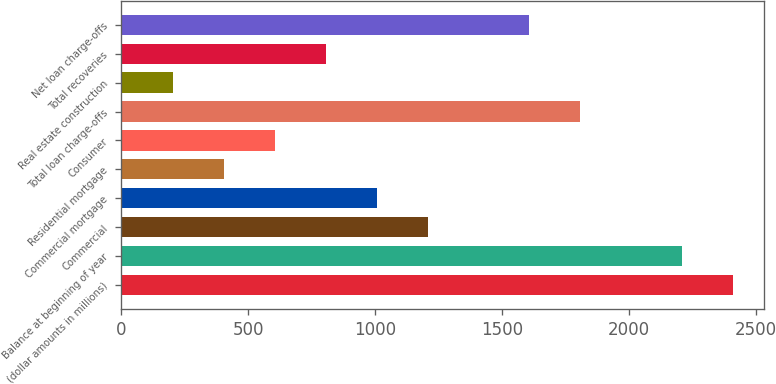Convert chart to OTSL. <chart><loc_0><loc_0><loc_500><loc_500><bar_chart><fcel>(dollar amounts in millions)<fcel>Balance at beginning of year<fcel>Commercial<fcel>Commercial mortgage<fcel>Residential mortgage<fcel>Consumer<fcel>Total loan charge-offs<fcel>Real estate construction<fcel>Total recoveries<fcel>Net loan charge-offs<nl><fcel>2411.71<fcel>2210.85<fcel>1206.55<fcel>1005.69<fcel>403.11<fcel>603.97<fcel>1809.13<fcel>202.25<fcel>804.83<fcel>1608.27<nl></chart> 